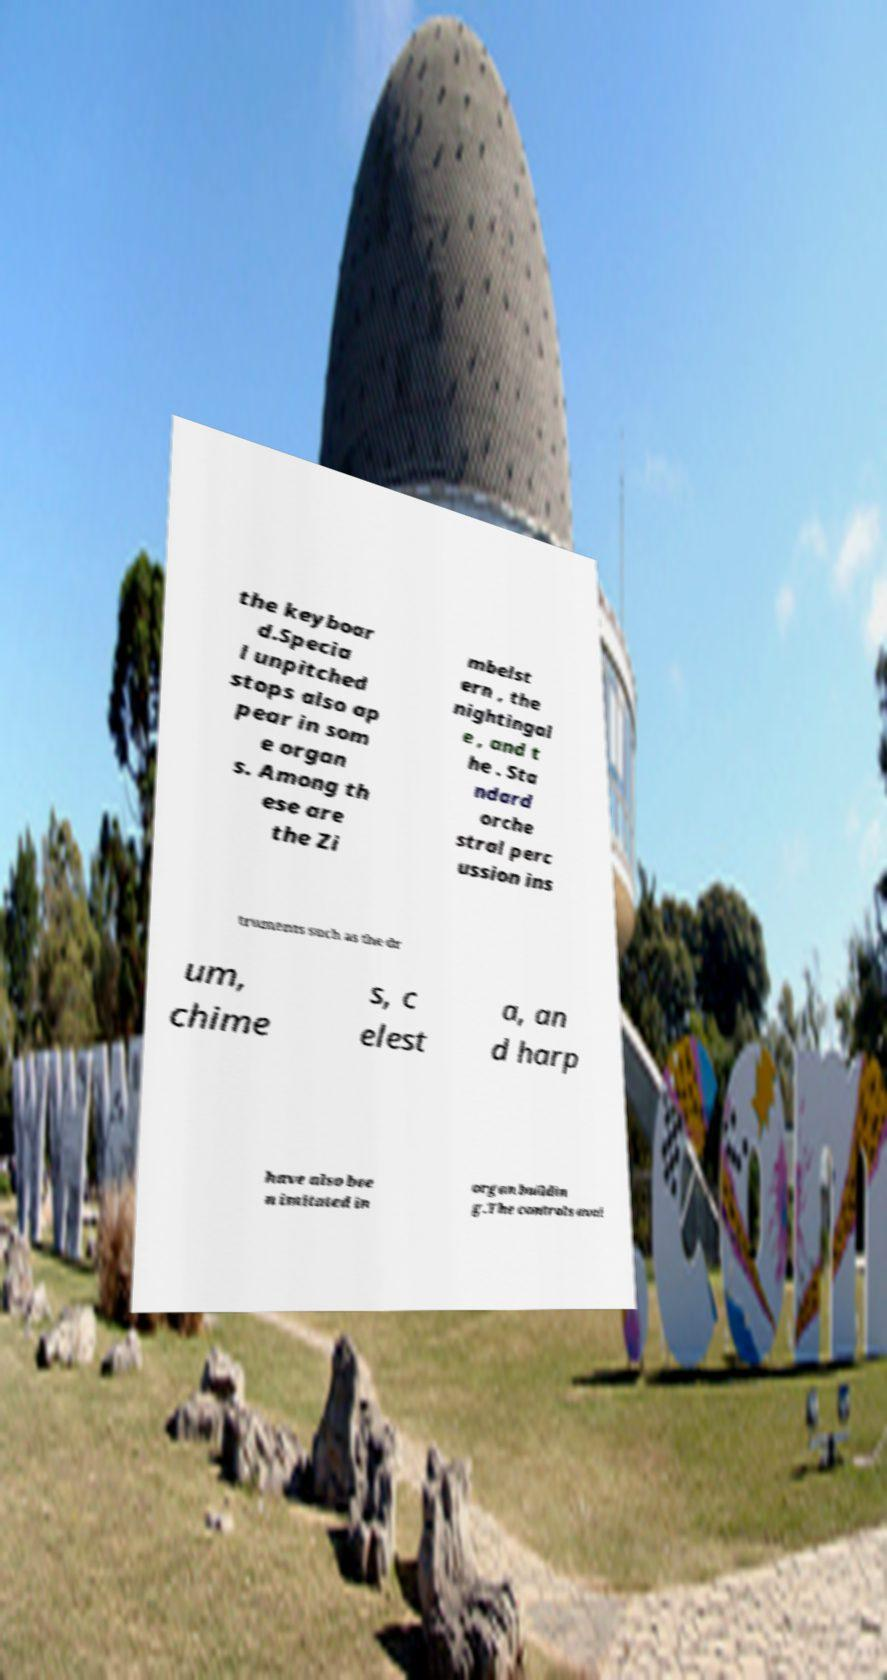Can you accurately transcribe the text from the provided image for me? the keyboar d.Specia l unpitched stops also ap pear in som e organ s. Among th ese are the Zi mbelst ern , the nightingal e , and t he . Sta ndard orche stral perc ussion ins truments such as the dr um, chime s, c elest a, an d harp have also bee n imitated in organ buildin g.The controls avai 